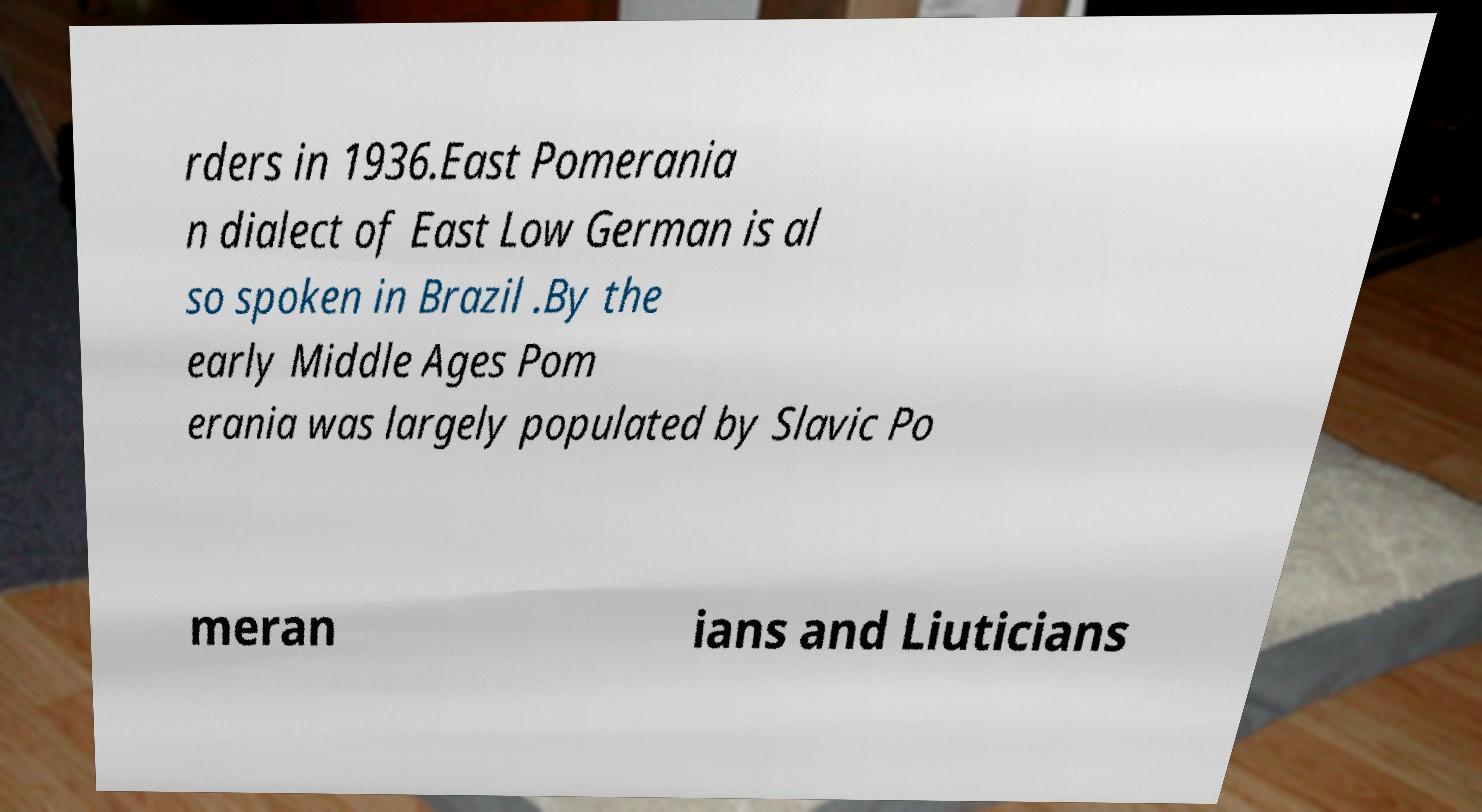Please identify and transcribe the text found in this image. rders in 1936.East Pomerania n dialect of East Low German is al so spoken in Brazil .By the early Middle Ages Pom erania was largely populated by Slavic Po meran ians and Liuticians 